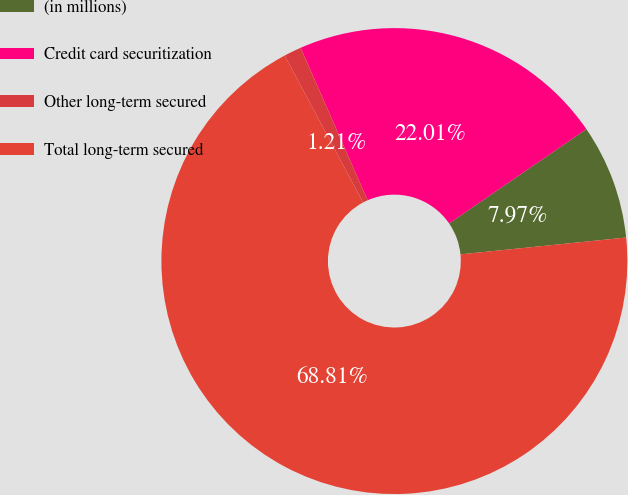Convert chart to OTSL. <chart><loc_0><loc_0><loc_500><loc_500><pie_chart><fcel>(in millions)<fcel>Credit card securitization<fcel>Other long-term secured<fcel>Total long-term secured<nl><fcel>7.97%<fcel>22.01%<fcel>1.21%<fcel>68.81%<nl></chart> 